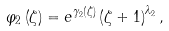<formula> <loc_0><loc_0><loc_500><loc_500>\varphi _ { 2 } \left ( \zeta \right ) = e ^ { \gamma _ { 2 } \left ( \zeta \right ) } \left ( \zeta + 1 \right ) ^ { \lambda _ { 2 } } ,</formula> 